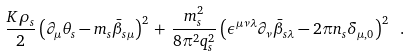<formula> <loc_0><loc_0><loc_500><loc_500>\frac { K \rho _ { s } } { 2 } \left ( \partial _ { \mu } \theta _ { s } - m _ { s } \bar { \beta } _ { s \mu } \right ) ^ { 2 } \, + \, \frac { m _ { s } ^ { 2 } } { 8 \pi ^ { 2 } q _ { s } ^ { 2 } } \left ( \epsilon ^ { \mu \nu \lambda } \partial _ { \nu } \bar { \beta } _ { s \lambda } - 2 \pi n _ { s } \delta _ { \mu , 0 } \right ) ^ { 2 } \ .</formula> 